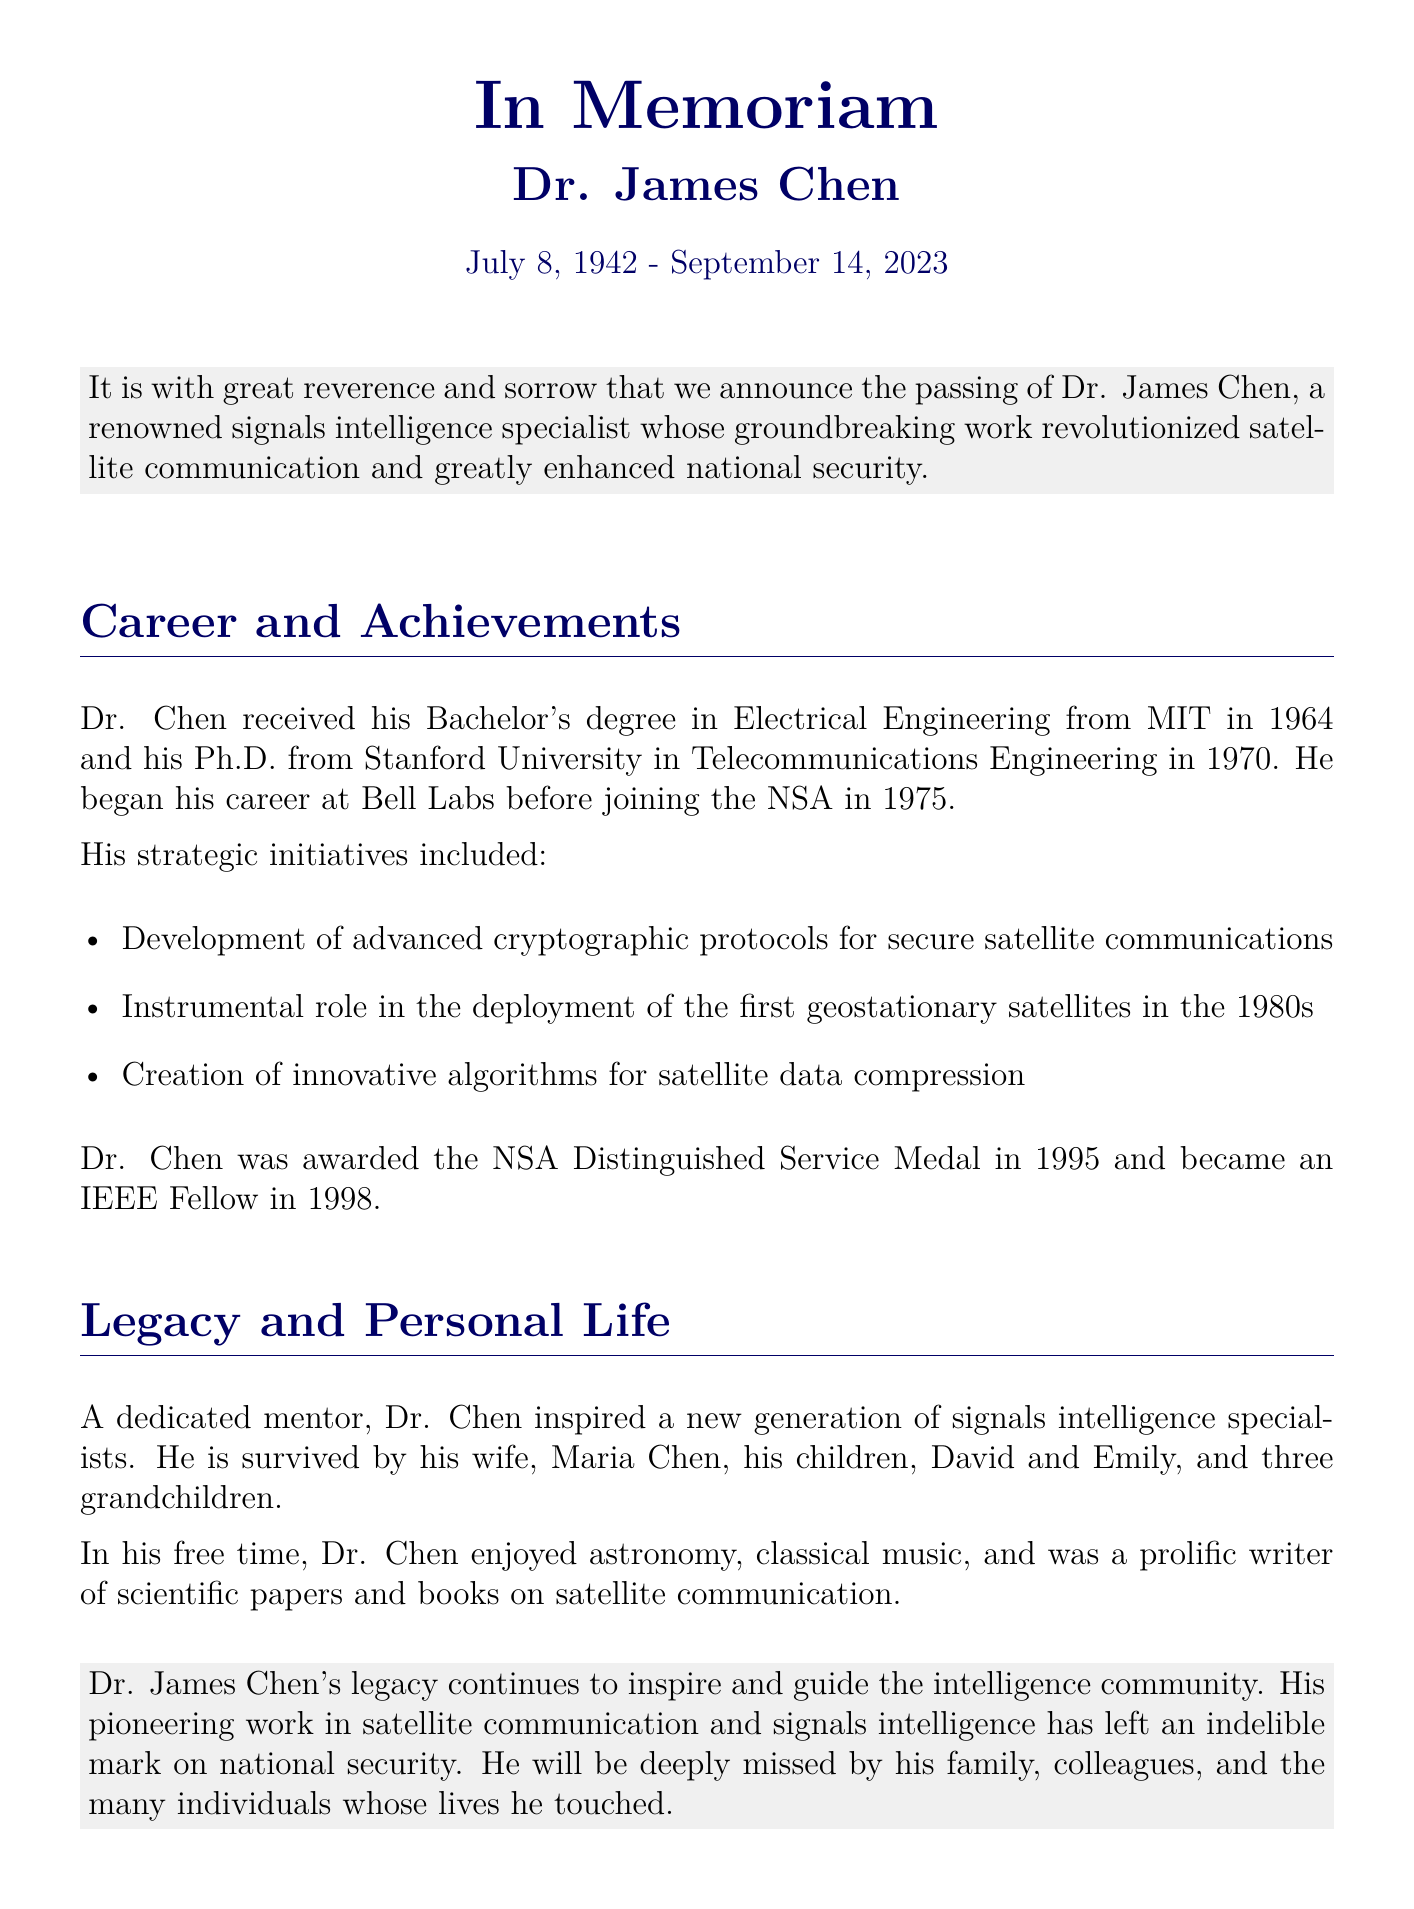What was Dr. James Chen's date of birth? The document states that Dr. James Chen was born on July 8, 1942.
Answer: July 8, 1942 What year did Dr. Chen join the NSA? The document indicates that he joined the NSA in 1975.
Answer: 1975 What prestigious award did Dr. Chen receive in 1995? The document mentions that he was awarded the NSA Distinguished Service Medal in 1995.
Answer: NSA Distinguished Service Medal Which university did Dr. Chen receive his Ph.D. from? The document specifies that he earned his Ph.D. from Stanford University.
Answer: Stanford University What role did Dr. Chen play in the 1980s? The document describes his instrumental role in the deployment of the first geostationary satellites in the 1980s.
Answer: Deployment of the first geostationary satellites What personal hobbies did Dr. Chen enjoy? According to the document, he enjoyed astronomy, classical music, and writing scientific papers.
Answer: Astronomy, classical music, writing What is the main focus of Dr. Chen's work? The document indicates that his work primarily focused on satellite communication and signals intelligence.
Answer: Satellite communication and signals intelligence Who are Dr. Chen's survivors mentioned in the obituary? The document mentions his wife, Maria Chen, and his children, David and Emily, as survivors.
Answer: Maria, David, Emily 